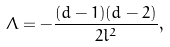Convert formula to latex. <formula><loc_0><loc_0><loc_500><loc_500>\ \Lambda = - \frac { ( d - 1 ) ( d - 2 ) } { 2 l ^ { 2 } } ,</formula> 